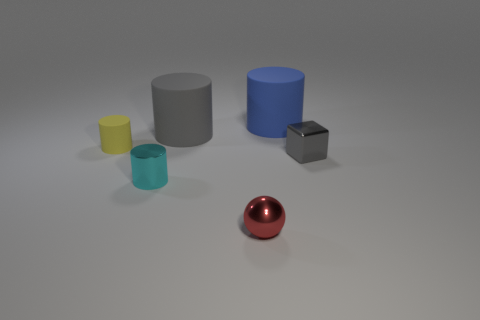There is a cylinder that is the same color as the tiny cube; what is it made of?
Your answer should be very brief. Rubber. There is a cylinder that is both in front of the large blue matte thing and to the right of the metal cylinder; what is its material?
Provide a succinct answer. Rubber. How many objects are either tiny gray rubber blocks or small rubber objects?
Make the answer very short. 1. Is the number of small cyan metal cylinders greater than the number of tiny gray metal balls?
Give a very brief answer. Yes. There is a metal block that is in front of the gray thing that is to the left of the gray metallic cube; what is its size?
Offer a very short reply. Small. The shiny thing that is the same shape as the yellow matte thing is what color?
Your answer should be compact. Cyan. The gray block has what size?
Offer a very short reply. Small. How many cylinders are gray shiny things or small cyan objects?
Provide a succinct answer. 1. The yellow matte thing that is the same shape as the small cyan object is what size?
Your answer should be compact. Small. What number of small shiny things are there?
Give a very brief answer. 3. 